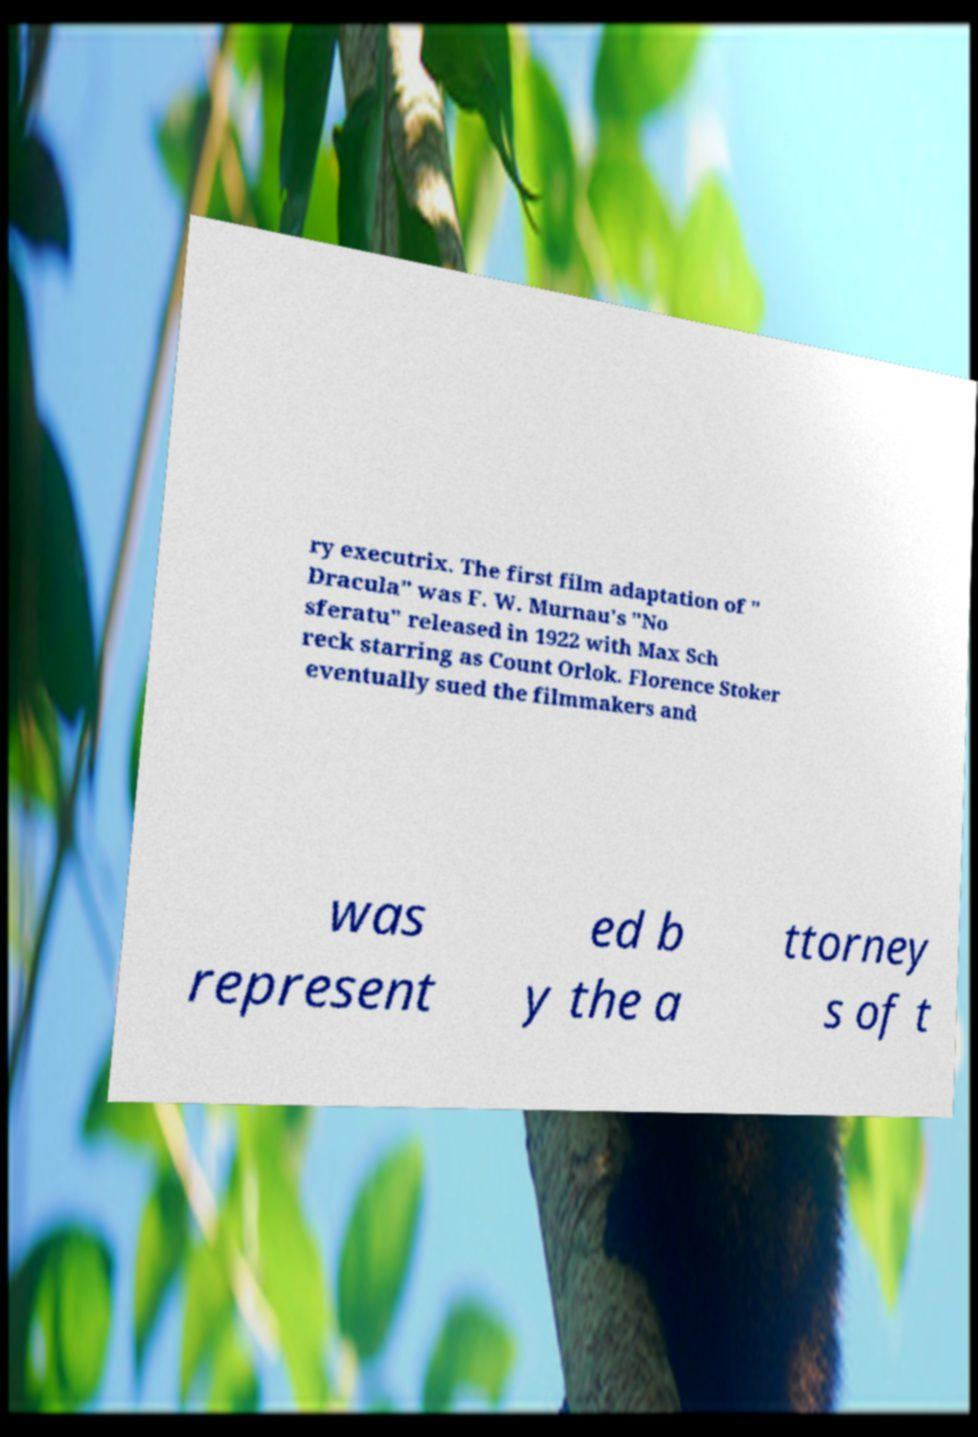Could you extract and type out the text from this image? ry executrix. The first film adaptation of " Dracula" was F. W. Murnau's "No sferatu" released in 1922 with Max Sch reck starring as Count Orlok. Florence Stoker eventually sued the filmmakers and was represent ed b y the a ttorney s of t 